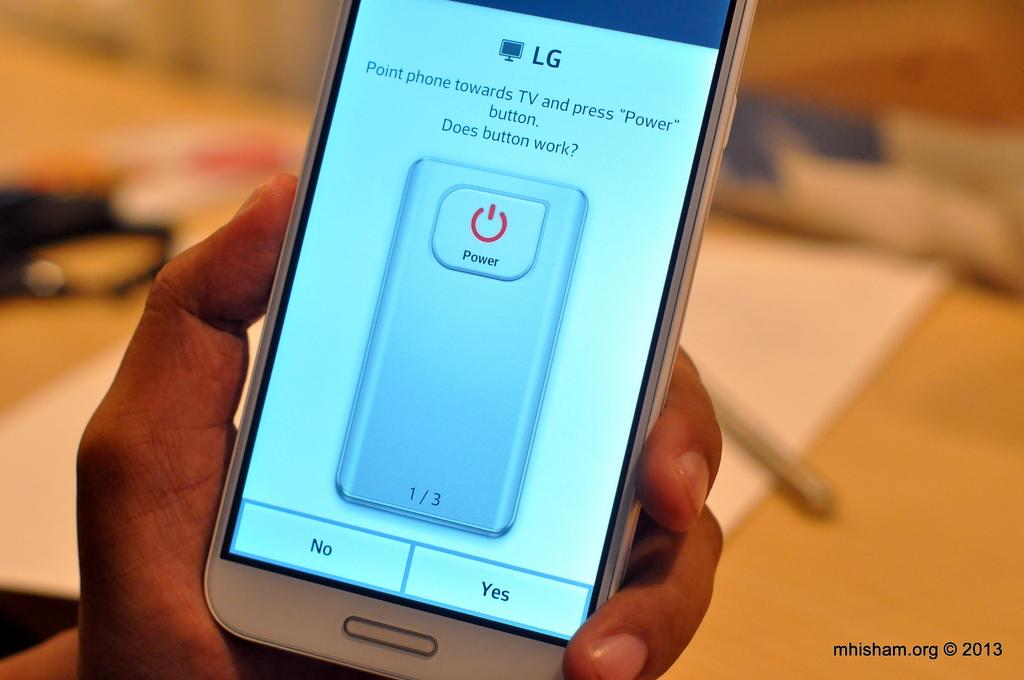<image>
Summarize the visual content of the image. a phone that has the word LG at the top of it 